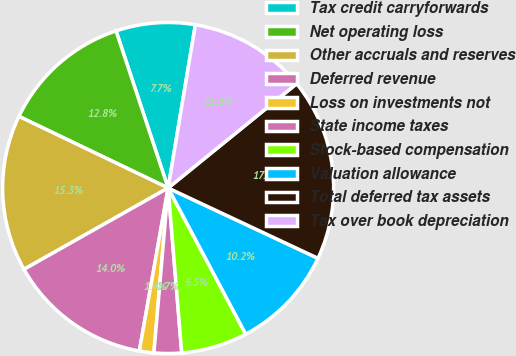Convert chart. <chart><loc_0><loc_0><loc_500><loc_500><pie_chart><fcel>Tax credit carryforwards<fcel>Net operating loss<fcel>Other accruals and reserves<fcel>Deferred revenue<fcel>Loss on investments not<fcel>State income taxes<fcel>Stock-based compensation<fcel>Valuation allowance<fcel>Total deferred tax assets<fcel>Tax over book depreciation<nl><fcel>7.73%<fcel>12.78%<fcel>15.3%<fcel>14.04%<fcel>1.41%<fcel>2.68%<fcel>6.46%<fcel>10.25%<fcel>17.83%<fcel>11.52%<nl></chart> 